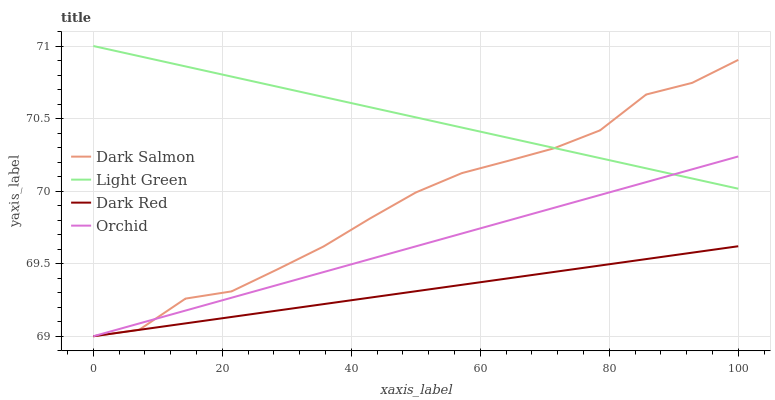Does Dark Salmon have the minimum area under the curve?
Answer yes or no. No. Does Dark Salmon have the maximum area under the curve?
Answer yes or no. No. Is Light Green the smoothest?
Answer yes or no. No. Is Light Green the roughest?
Answer yes or no. No. Does Light Green have the lowest value?
Answer yes or no. No. Does Dark Salmon have the highest value?
Answer yes or no. No. Is Dark Red less than Light Green?
Answer yes or no. Yes. Is Light Green greater than Dark Red?
Answer yes or no. Yes. Does Dark Red intersect Light Green?
Answer yes or no. No. 